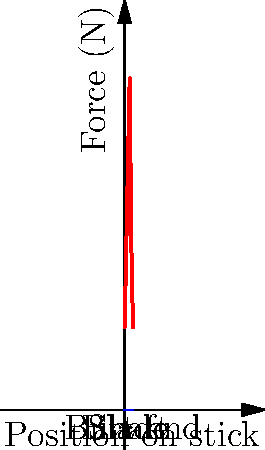During a face-off, the force distribution along a hockey stick varies. Based on the graph, which area of the stick experiences the highest impact force, and approximately how much force (in Newtons) is applied at that point? To answer this question, we need to analyze the graph carefully:

1. The x-axis represents the position along the hockey stick, from the blade (0) to the butt end (5).
2. The y-axis shows the force in Newtons (N) applied at each point.
3. We can see that the graph peaks at a certain point, which represents the maximum force.
4. This peak occurs at position 3 on the x-axis, which corresponds to the middle of the shaft.
5. The y-value at this peak is approximately 200 N.

Therefore, the area of the stick that experiences the highest impact force during a face-off is the middle of the shaft, and the maximum force applied is about 200 N.

This distribution makes sense biomechanically:
- The blade experiences moderate force as it contacts the puck.
- The force increases along the shaft as it absorbs and transmits the impact.
- The middle of the shaft experiences the highest force due to leverage and flex.
- The force decreases towards the butt end, where the player's top hand provides control.
Answer: Middle of the shaft, 200 N 